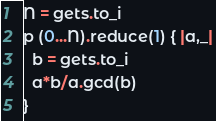Convert code to text. <code><loc_0><loc_0><loc_500><loc_500><_Ruby_>N = gets.to_i
p (0...N).reduce(1) { |a,_|
  b = gets.to_i
  a*b/a.gcd(b)
}</code> 